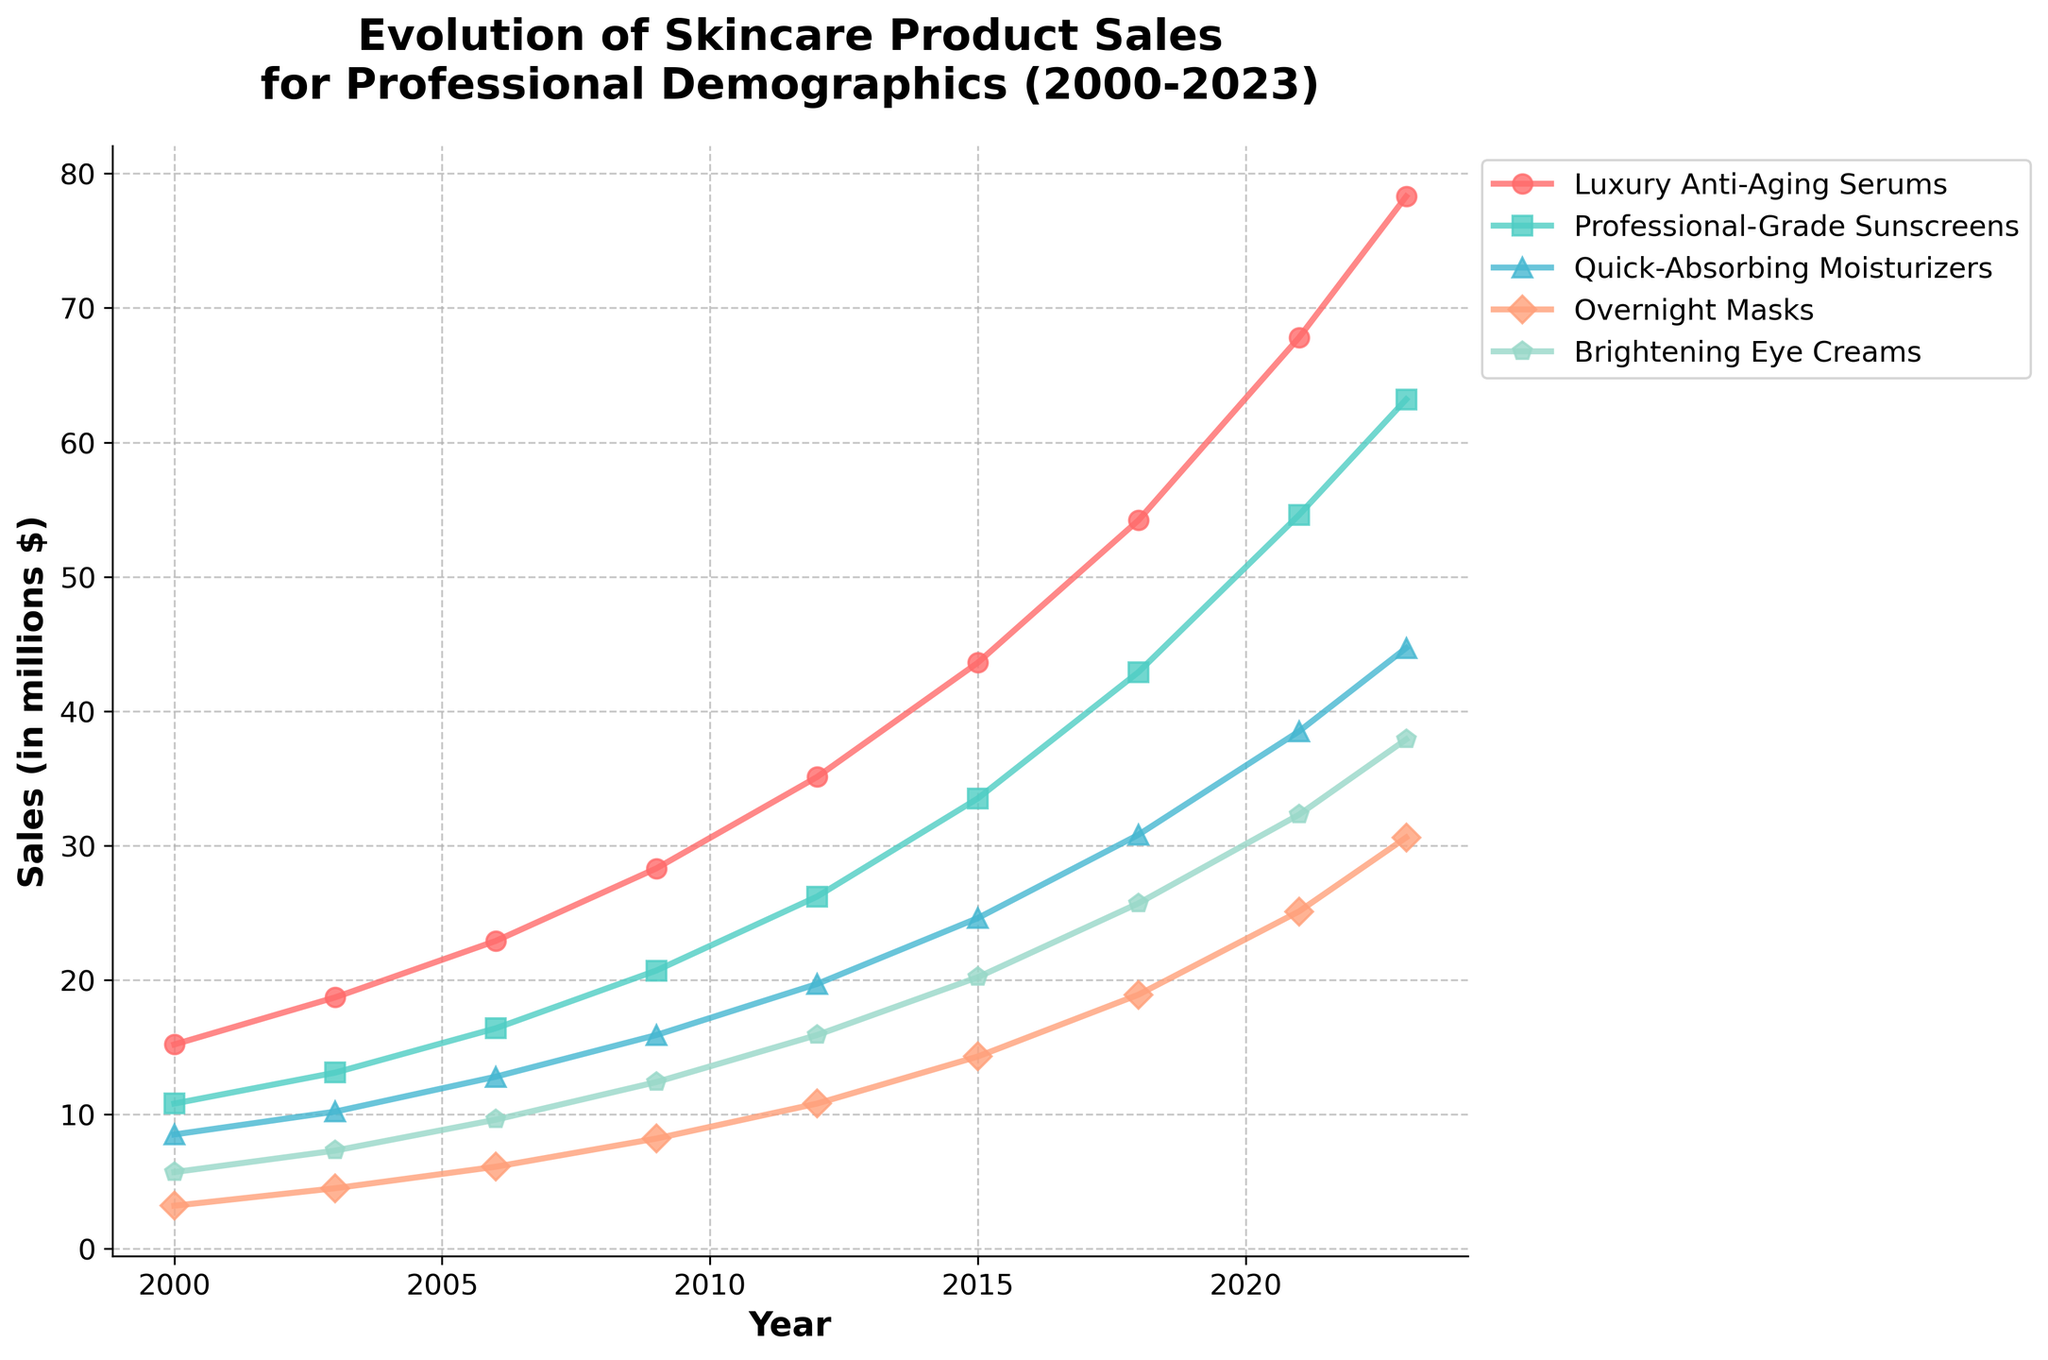What skincare product had the highest sales in 2023? Look at the endpoints of all the lines representing different products in 2023; the line that reaches the highest vertical point on the axis shows the product with the highest sales.
Answer: Luxury Anti-Aging Serums Which skincare product experienced the most significant overall increase in sales from 2000 to 2023? Calculate the difference in sales from 2000 to 2023 for each product. The product with the highest difference has experienced the most significant increase.
Answer: Luxury Anti-Aging Serums Compare the sales of Professional-Grade Sunscreens and Quick-Absorbing Moisturizers in 2015. Which one had higher sales? Find the data points for both products in 2015 and compare their heights on the vertical axis.
Answer: Professional-Grade Sunscreens What is the combined sales of Brightening Eye Creams and Overnight Masks in 2021? Add the sales figures for Brightening Eye Creams and Overnight Masks in 2021. The sales of Brightening Eye Creams are 32.3 and for Overnight Masks are 25.1. So, 32.3 + 25.1 = 57.4.
Answer: 57.4 million $ Which product had the least sales growth between 2018 and 2021? Calculate the difference in sales for each product between the years 2018 and 2021, then identify which product had the smallest difference.
Answer: Overnight Masks How do the trends in sales for Luxury Anti-Aging Serums compare to Brightening Eye Creams over the period? Visually inspect the slope of the lines for Luxury Anti-Aging Serums and Brightening Eye Creams. The steeper line indicates a faster growth rate, while a less steep line indicates a slower growth. Both lines are increasing but Luxury Anti-Aging Serums show a steeper and more consistent upward trend.
Answer: Luxury Anti-Aging Serums has a steeper trend Between which two consecutive years did Professional-Grade Sunscreens experience the highest increase in sales? Examine the slopes of the segments connecting each pair of consecutive years for Professional-Grade Sunscreens. The steepest segment indicates the highest increase.
Answer: 2011 to 2014 (from 35.1 to 43.6) What was the difference in sales of Quick-Absorbing Moisturizers between 2000 and 2023? Subtract the sales figure of Quick-Absorbing Moisturizers in 2000 from its sales in 2023. 44.7 - 8.5 = 36.2.
Answer: 36.2 million $ By how much did the sales of Overnight Masks increase between 2009 and 2018? Subtract the sales figure of Overnight Masks in 2009 from its sales in 2018. 18.9 - 8.2 = 10.7.
Answer: 10.7 million $ Considering all years, which skincare product consistently shows higher sales than Brightening Eye Creams? Compare the line representing Brightening Eye Creams with the other lines over the entire period. The line for Luxury Anti-Aging Serums is always above Brightening Eye Creams.
Answer: Luxury Anti-Aging Serums 